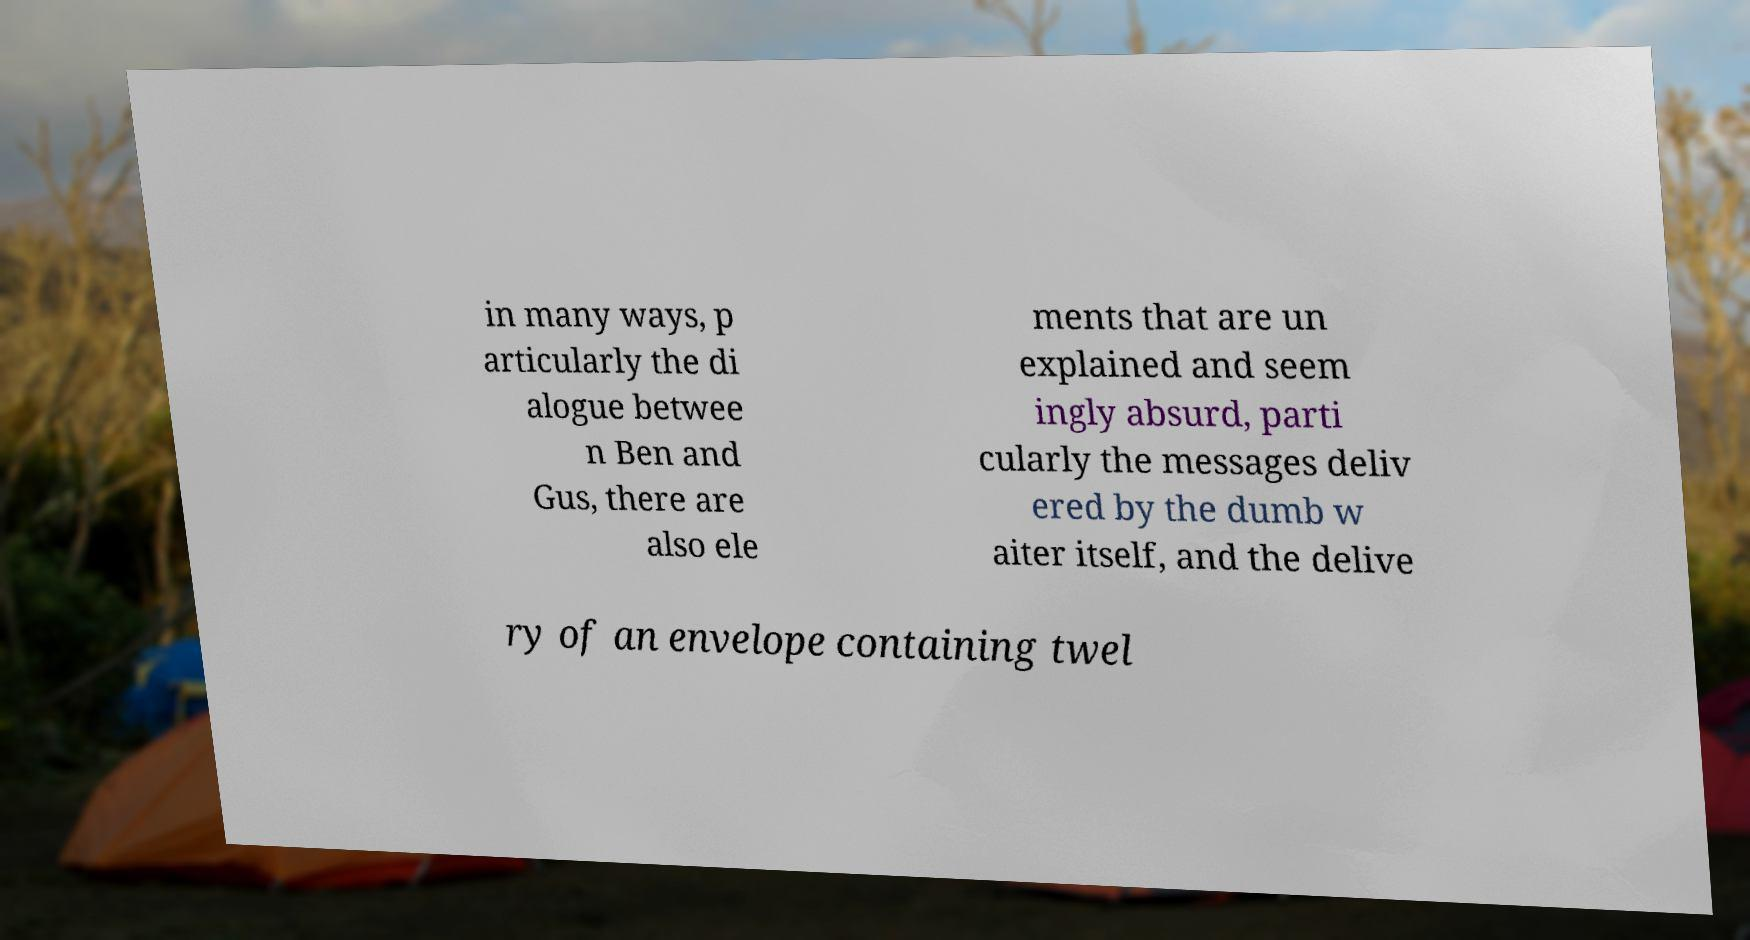Please identify and transcribe the text found in this image. in many ways, p articularly the di alogue betwee n Ben and Gus, there are also ele ments that are un explained and seem ingly absurd, parti cularly the messages deliv ered by the dumb w aiter itself, and the delive ry of an envelope containing twel 